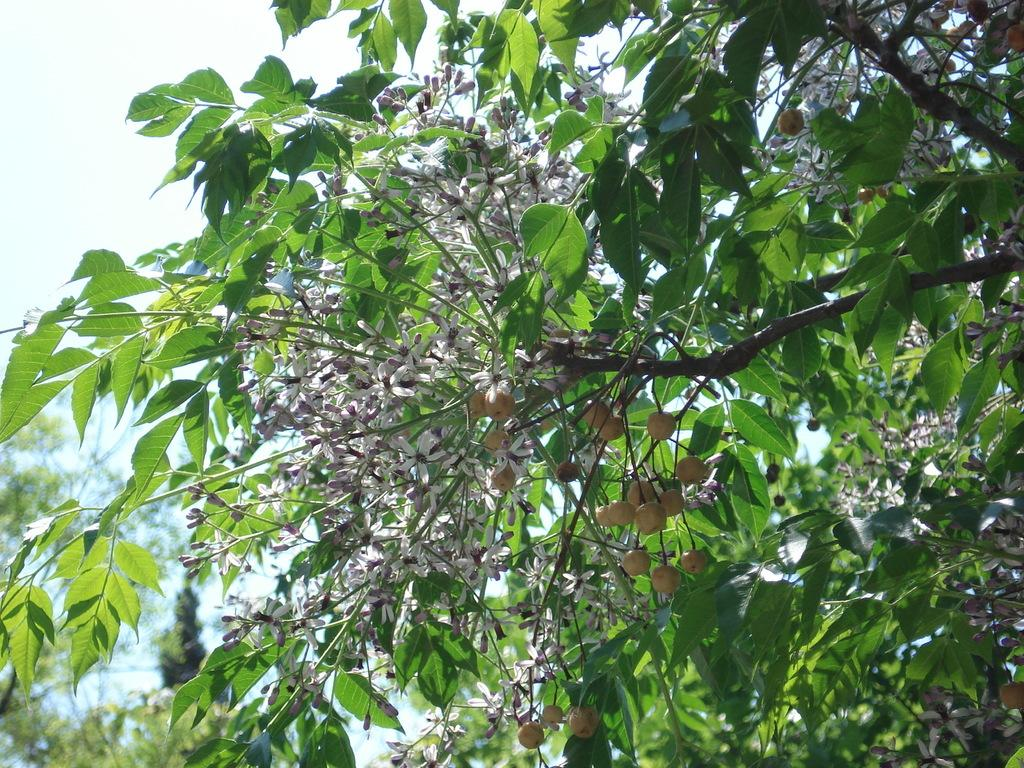What can be seen at the top of the image? The sky is visible towards the top of the image. What type of vegetation is present in the image? There are trees in the image. What type of food items can be seen in the image? There are fruits in the image. What other natural elements are present in the image? There are flowers in the image. What type of farm animals can be seen in the image? There are no farm animals present in the image. What is the end result of the crib in the image? There is no crib present in the image. 